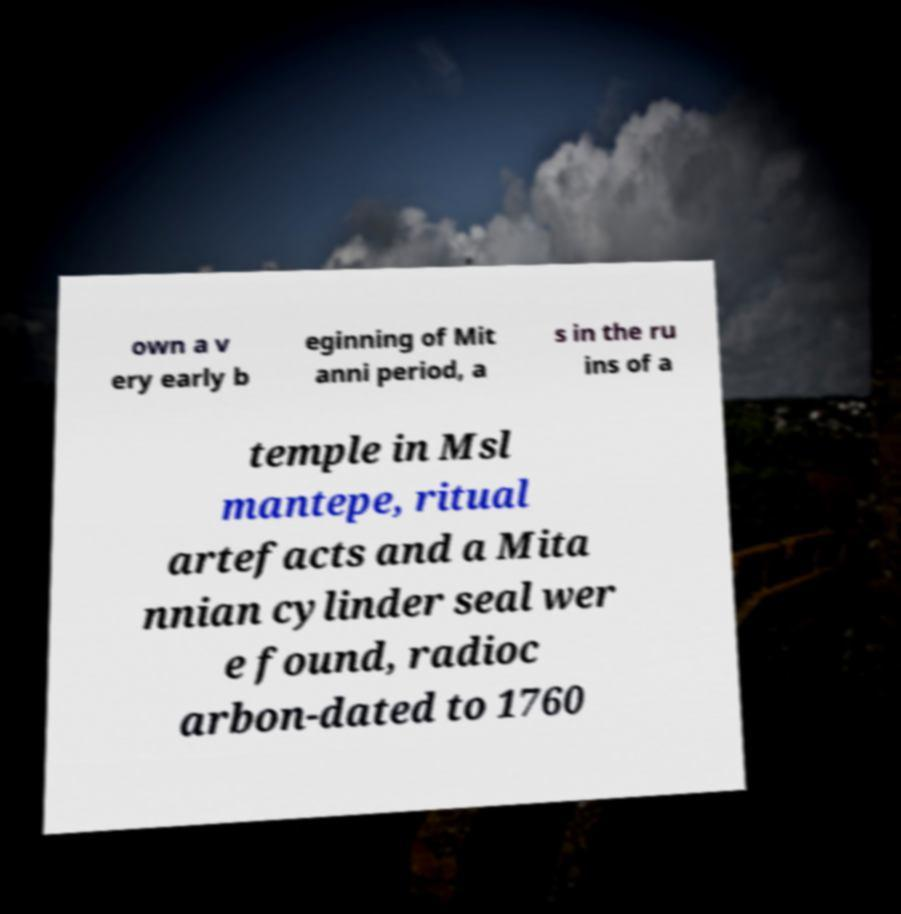For documentation purposes, I need the text within this image transcribed. Could you provide that? own a v ery early b eginning of Mit anni period, a s in the ru ins of a temple in Msl mantepe, ritual artefacts and a Mita nnian cylinder seal wer e found, radioc arbon-dated to 1760 